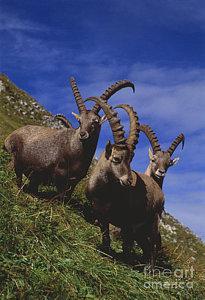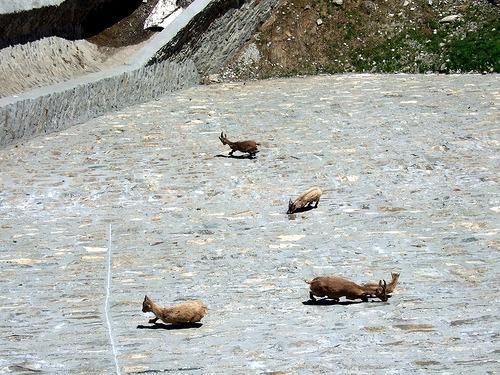The first image is the image on the left, the second image is the image on the right. Assess this claim about the two images: "The right photo contains three or more animals.". Correct or not? Answer yes or no. Yes. 